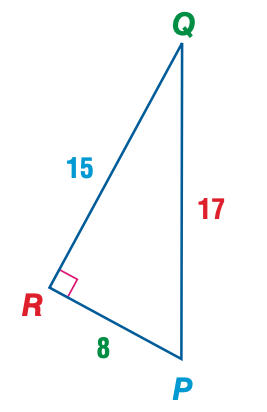Answer the mathemtical geometry problem and directly provide the correct option letter.
Question: Express the ratio of \tan Q as a decimal to the nearest hundredth.
Choices: A: 0.47 B: 0.53 C: 0.88 D: 1.88 B 